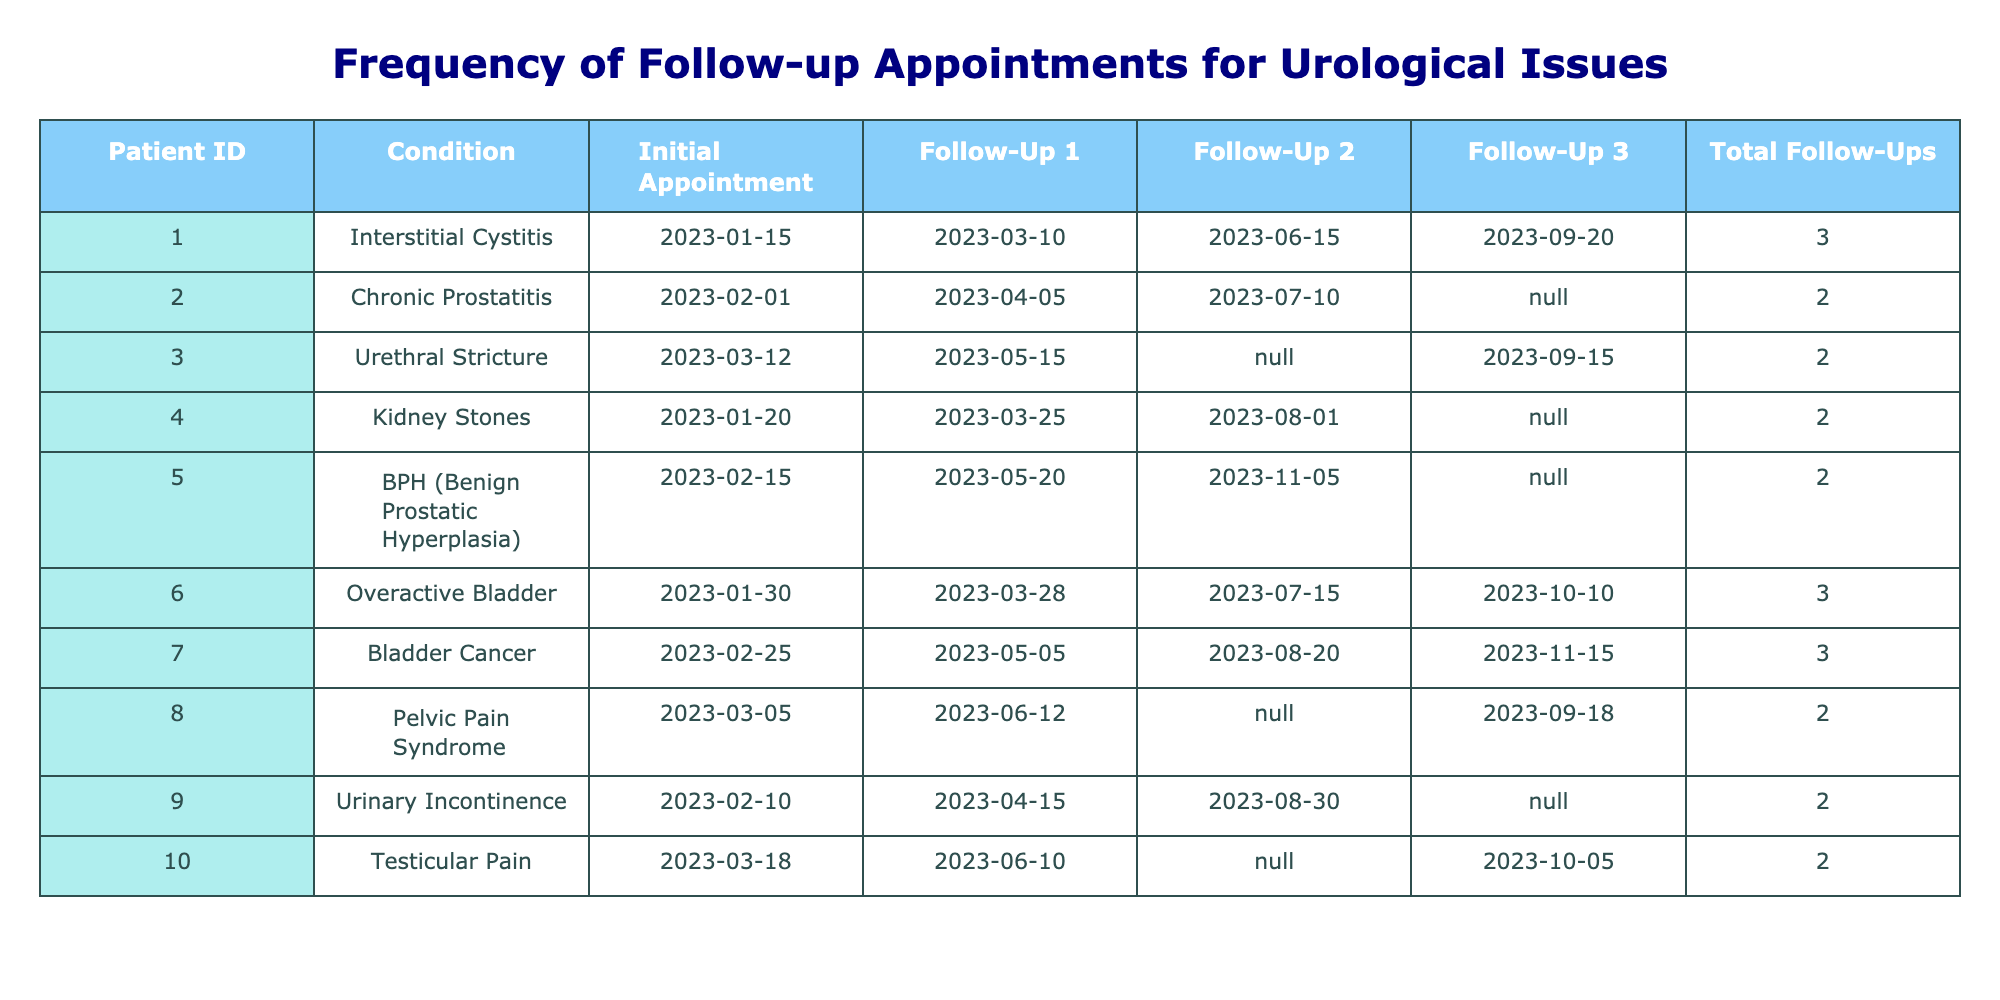What is the condition of Patient 5? By referring to the 'Condition' column in the table, we can find Patient 5, whose condition is listed as "BPH (Benign Prostatic Hyperplasia)."
Answer: BPH (Benign Prostatic Hyperplasia) How many follow-up appointments did Patient 7 have? Looking at the 'Total Follow-Ups' column, Patient 7 is indicated to have had a total of 3 follow-up appointments.
Answer: 3 Which patient had the most follow-up appointments? By comparing the 'Total Follow-Ups' columns, Patients 1, 6, and 7 each have 3 follow-ups, which is the highest in the table. Hence, there isn't a single unique patient with the most follow-ups.
Answer: Patients 1, 6, and 7 (3 each) Is there a patient who had no follow-up appointments scheduled after their initial appointment? Checking the follow-up date columns, we can see that there are no empty slots for all patients. Thus, there are patients like Patient 2, Patient 3, Patient 4, and Patient 5 who have one empty cell signifying they missed a follow-up appointment but did not have zero follow-up appointments scheduled.
Answer: Yes, there are patients with missing follow-up appointments What is the average number of follow-up appointments across all patients? The total number of follow-up appointments is 18 (sum of all follow-ups), and there are 10 patients. Therefore, we calculate the average as 18 total appointments / 10 patients = 1.8.
Answer: 1.8 How many patients had exactly two follow-up appointments? By counting the patients in the 'Total Follow-Ups' column that show a value of 2, we see that Patients 2, 3, 4, 5, 8, 9, and 10 each had exactly 2 follow-up appointments, totaling 7 patients.
Answer: 7 Which condition corresponds to the patient with the earliest follow-up date? From the table, we first identify the earliest follow-up date, which is on '2023-03-10' corresponding to Patient 1. Their condition is "Interstitial Cystitis."
Answer: Interstitial Cystitis What is the difference in the number of follow-ups between the patient with the most and the patient with the least follow-ups? Patient 1, 6, and 7 have the maximum at 3 follow-ups, while patients like Patient 2, 3, 4, 5, 8, 9, and 10 have 2, which makes the least 0. Therefore, the difference is 3 - 2 = 1.
Answer: 1 How many patients had their follow-up dates on the same days? By analyzing the follow-up columns, we see that Patients 2, 3, and 5 have their follow-ups on the same day; however, Patient 2 has different follow-up dates overall. Therefore, the overlapping count results in at least 1 patient having the same follow-up date on multiple occasions.
Answer: At least 1 